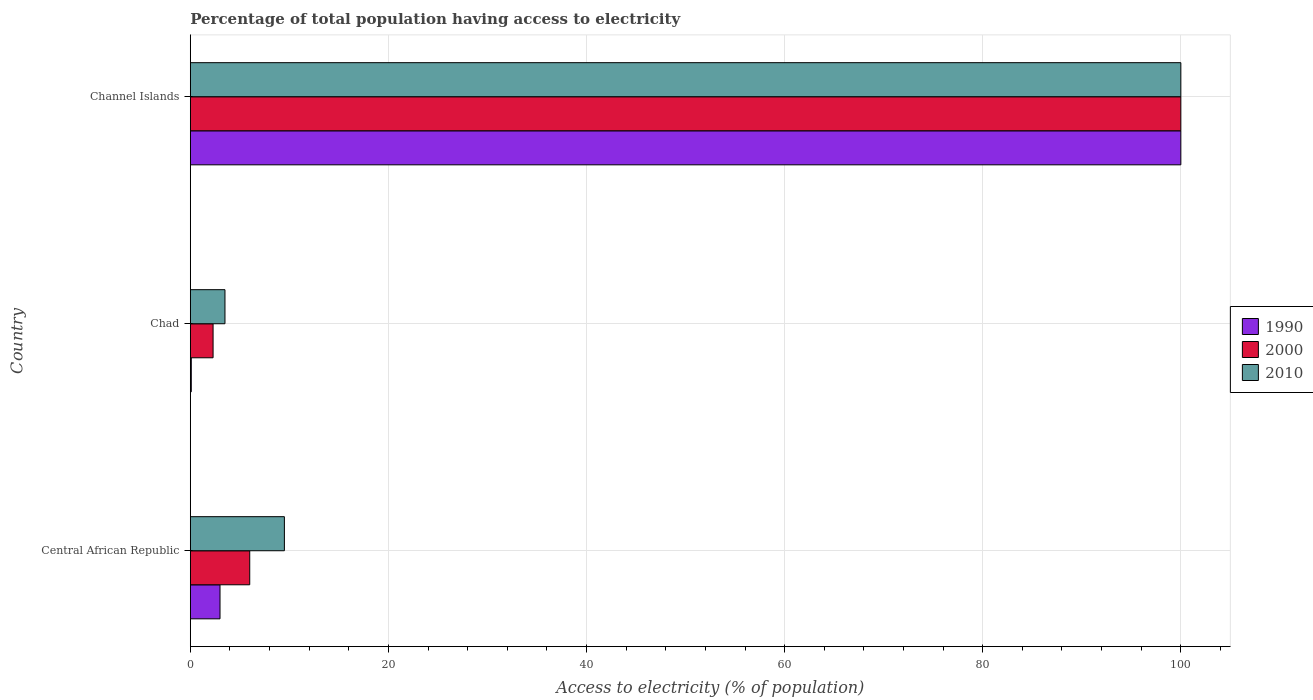How many groups of bars are there?
Offer a terse response. 3. What is the label of the 1st group of bars from the top?
Provide a short and direct response. Channel Islands. What is the percentage of population that have access to electricity in 1990 in Central African Republic?
Provide a short and direct response. 3. Across all countries, what is the minimum percentage of population that have access to electricity in 2000?
Provide a short and direct response. 2.3. In which country was the percentage of population that have access to electricity in 2000 maximum?
Your answer should be very brief. Channel Islands. In which country was the percentage of population that have access to electricity in 1990 minimum?
Offer a very short reply. Chad. What is the total percentage of population that have access to electricity in 2000 in the graph?
Your answer should be compact. 108.3. What is the difference between the percentage of population that have access to electricity in 2010 in Chad and that in Channel Islands?
Ensure brevity in your answer.  -96.5. What is the difference between the percentage of population that have access to electricity in 1990 in Central African Republic and the percentage of population that have access to electricity in 2000 in Chad?
Your response must be concise. 0.7. What is the average percentage of population that have access to electricity in 2010 per country?
Your response must be concise. 37.67. What is the difference between the percentage of population that have access to electricity in 2000 and percentage of population that have access to electricity in 2010 in Chad?
Your answer should be very brief. -1.2. In how many countries, is the percentage of population that have access to electricity in 2010 greater than 8 %?
Give a very brief answer. 2. What is the ratio of the percentage of population that have access to electricity in 2010 in Central African Republic to that in Channel Islands?
Provide a succinct answer. 0.1. Is the percentage of population that have access to electricity in 2010 in Central African Republic less than that in Chad?
Ensure brevity in your answer.  No. Is the difference between the percentage of population that have access to electricity in 2000 in Central African Republic and Chad greater than the difference between the percentage of population that have access to electricity in 2010 in Central African Republic and Chad?
Make the answer very short. No. What is the difference between the highest and the second highest percentage of population that have access to electricity in 2010?
Offer a very short reply. 90.5. What is the difference between the highest and the lowest percentage of population that have access to electricity in 1990?
Make the answer very short. 99.9. In how many countries, is the percentage of population that have access to electricity in 2010 greater than the average percentage of population that have access to electricity in 2010 taken over all countries?
Your answer should be very brief. 1. Is the sum of the percentage of population that have access to electricity in 2010 in Chad and Channel Islands greater than the maximum percentage of population that have access to electricity in 1990 across all countries?
Provide a short and direct response. Yes. What does the 2nd bar from the bottom in Central African Republic represents?
Give a very brief answer. 2000. How many bars are there?
Make the answer very short. 9. What is the difference between two consecutive major ticks on the X-axis?
Make the answer very short. 20. Does the graph contain grids?
Ensure brevity in your answer.  Yes. How many legend labels are there?
Your response must be concise. 3. What is the title of the graph?
Offer a very short reply. Percentage of total population having access to electricity. Does "2000" appear as one of the legend labels in the graph?
Give a very brief answer. Yes. What is the label or title of the X-axis?
Make the answer very short. Access to electricity (% of population). What is the Access to electricity (% of population) of 1990 in Central African Republic?
Make the answer very short. 3. What is the Access to electricity (% of population) in 2010 in Channel Islands?
Make the answer very short. 100. Across all countries, what is the maximum Access to electricity (% of population) in 1990?
Give a very brief answer. 100. Across all countries, what is the maximum Access to electricity (% of population) of 2000?
Offer a very short reply. 100. Across all countries, what is the minimum Access to electricity (% of population) of 1990?
Give a very brief answer. 0.1. What is the total Access to electricity (% of population) in 1990 in the graph?
Your answer should be very brief. 103.1. What is the total Access to electricity (% of population) in 2000 in the graph?
Provide a short and direct response. 108.3. What is the total Access to electricity (% of population) of 2010 in the graph?
Your answer should be compact. 113. What is the difference between the Access to electricity (% of population) in 1990 in Central African Republic and that in Chad?
Your answer should be compact. 2.9. What is the difference between the Access to electricity (% of population) in 2010 in Central African Republic and that in Chad?
Give a very brief answer. 6. What is the difference between the Access to electricity (% of population) of 1990 in Central African Republic and that in Channel Islands?
Ensure brevity in your answer.  -97. What is the difference between the Access to electricity (% of population) of 2000 in Central African Republic and that in Channel Islands?
Offer a terse response. -94. What is the difference between the Access to electricity (% of population) in 2010 in Central African Republic and that in Channel Islands?
Provide a short and direct response. -90.5. What is the difference between the Access to electricity (% of population) in 1990 in Chad and that in Channel Islands?
Offer a terse response. -99.9. What is the difference between the Access to electricity (% of population) in 2000 in Chad and that in Channel Islands?
Keep it short and to the point. -97.7. What is the difference between the Access to electricity (% of population) in 2010 in Chad and that in Channel Islands?
Provide a short and direct response. -96.5. What is the difference between the Access to electricity (% of population) of 1990 in Central African Republic and the Access to electricity (% of population) of 2000 in Channel Islands?
Give a very brief answer. -97. What is the difference between the Access to electricity (% of population) in 1990 in Central African Republic and the Access to electricity (% of population) in 2010 in Channel Islands?
Offer a terse response. -97. What is the difference between the Access to electricity (% of population) in 2000 in Central African Republic and the Access to electricity (% of population) in 2010 in Channel Islands?
Ensure brevity in your answer.  -94. What is the difference between the Access to electricity (% of population) in 1990 in Chad and the Access to electricity (% of population) in 2000 in Channel Islands?
Your answer should be very brief. -99.9. What is the difference between the Access to electricity (% of population) of 1990 in Chad and the Access to electricity (% of population) of 2010 in Channel Islands?
Offer a very short reply. -99.9. What is the difference between the Access to electricity (% of population) in 2000 in Chad and the Access to electricity (% of population) in 2010 in Channel Islands?
Provide a short and direct response. -97.7. What is the average Access to electricity (% of population) of 1990 per country?
Your response must be concise. 34.37. What is the average Access to electricity (% of population) of 2000 per country?
Keep it short and to the point. 36.1. What is the average Access to electricity (% of population) in 2010 per country?
Ensure brevity in your answer.  37.67. What is the difference between the Access to electricity (% of population) of 1990 and Access to electricity (% of population) of 2010 in Central African Republic?
Make the answer very short. -6.5. What is the difference between the Access to electricity (% of population) in 2000 and Access to electricity (% of population) in 2010 in Central African Republic?
Your answer should be compact. -3.5. What is the difference between the Access to electricity (% of population) of 1990 and Access to electricity (% of population) of 2010 in Chad?
Offer a very short reply. -3.4. What is the difference between the Access to electricity (% of population) of 2000 and Access to electricity (% of population) of 2010 in Channel Islands?
Keep it short and to the point. 0. What is the ratio of the Access to electricity (% of population) in 1990 in Central African Republic to that in Chad?
Your answer should be very brief. 30. What is the ratio of the Access to electricity (% of population) of 2000 in Central African Republic to that in Chad?
Your answer should be compact. 2.61. What is the ratio of the Access to electricity (% of population) in 2010 in Central African Republic to that in Chad?
Your answer should be very brief. 2.71. What is the ratio of the Access to electricity (% of population) in 1990 in Central African Republic to that in Channel Islands?
Offer a very short reply. 0.03. What is the ratio of the Access to electricity (% of population) of 2000 in Central African Republic to that in Channel Islands?
Provide a succinct answer. 0.06. What is the ratio of the Access to electricity (% of population) in 2010 in Central African Republic to that in Channel Islands?
Keep it short and to the point. 0.1. What is the ratio of the Access to electricity (% of population) in 2000 in Chad to that in Channel Islands?
Provide a succinct answer. 0.02. What is the ratio of the Access to electricity (% of population) of 2010 in Chad to that in Channel Islands?
Your response must be concise. 0.04. What is the difference between the highest and the second highest Access to electricity (% of population) of 1990?
Provide a succinct answer. 97. What is the difference between the highest and the second highest Access to electricity (% of population) of 2000?
Offer a very short reply. 94. What is the difference between the highest and the second highest Access to electricity (% of population) in 2010?
Make the answer very short. 90.5. What is the difference between the highest and the lowest Access to electricity (% of population) of 1990?
Keep it short and to the point. 99.9. What is the difference between the highest and the lowest Access to electricity (% of population) of 2000?
Make the answer very short. 97.7. What is the difference between the highest and the lowest Access to electricity (% of population) in 2010?
Make the answer very short. 96.5. 